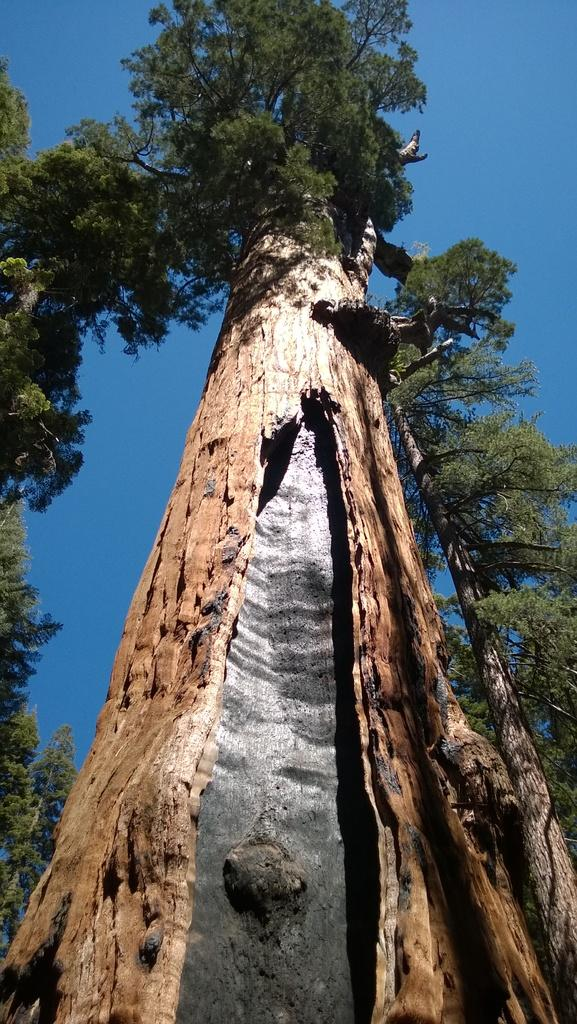What is the main subject in the center of the image? There is a tree in the center of the image. What can be seen on the left side of the image? There are trees on the left side of the image. What is present on the right side of the image? There are trees on the right side of the image. What is visible above the trees in the image? The sky is visible in the image. What type of car is parked at the base of the tree in the image? There is no car present in the image; it only features trees and the sky. 